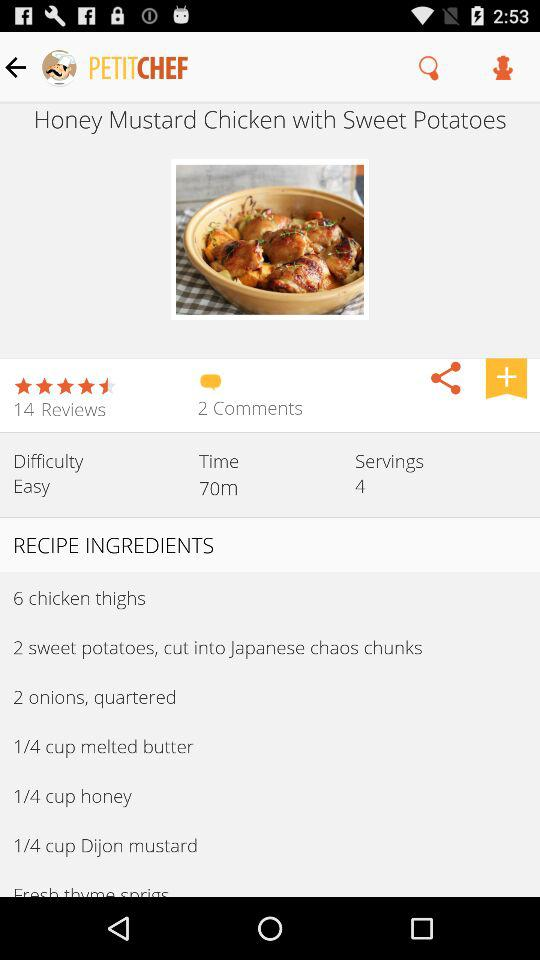What is the total number of servings? The total number of servings is 4. 